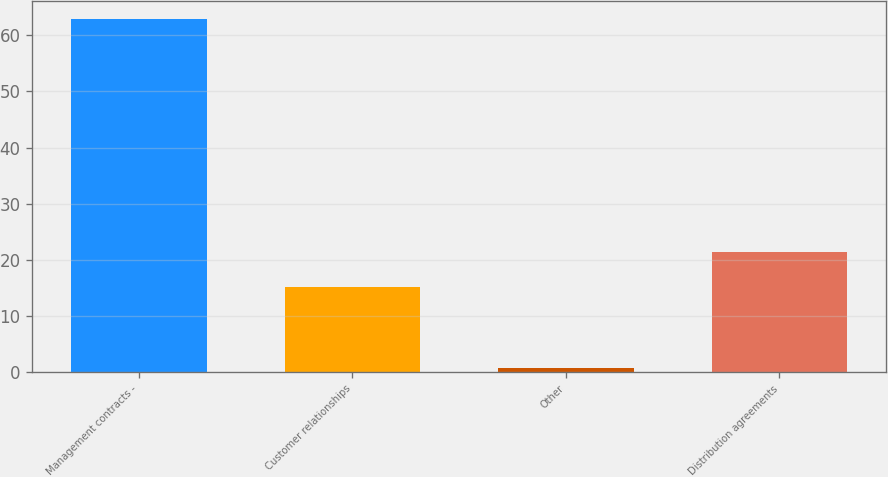Convert chart to OTSL. <chart><loc_0><loc_0><loc_500><loc_500><bar_chart><fcel>Management contracts -<fcel>Customer relationships<fcel>Other<fcel>Distribution agreements<nl><fcel>62.9<fcel>15.2<fcel>0.7<fcel>21.42<nl></chart> 